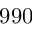Convert formula to latex. <formula><loc_0><loc_0><loc_500><loc_500>9 9 0</formula> 